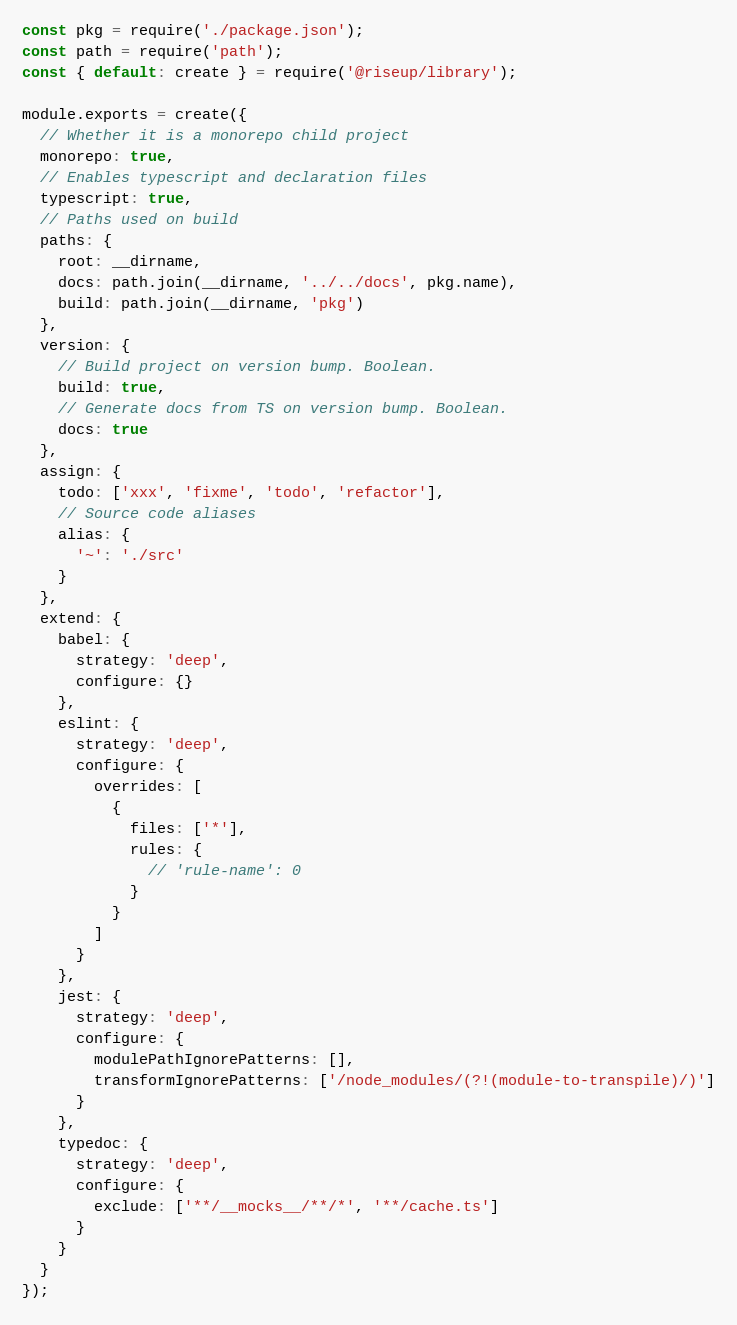<code> <loc_0><loc_0><loc_500><loc_500><_JavaScript_>const pkg = require('./package.json');
const path = require('path');
const { default: create } = require('@riseup/library');

module.exports = create({
  // Whether it is a monorepo child project
  monorepo: true,
  // Enables typescript and declaration files
  typescript: true,
  // Paths used on build
  paths: {
    root: __dirname,
    docs: path.join(__dirname, '../../docs', pkg.name),
    build: path.join(__dirname, 'pkg')
  },
  version: {
    // Build project on version bump. Boolean.
    build: true,
    // Generate docs from TS on version bump. Boolean.
    docs: true
  },
  assign: {
    todo: ['xxx', 'fixme', 'todo', 'refactor'],
    // Source code aliases
    alias: {
      '~': './src'
    }
  },
  extend: {
    babel: {
      strategy: 'deep',
      configure: {}
    },
    eslint: {
      strategy: 'deep',
      configure: {
        overrides: [
          {
            files: ['*'],
            rules: {
              // 'rule-name': 0
            }
          }
        ]
      }
    },
    jest: {
      strategy: 'deep',
      configure: {
        modulePathIgnorePatterns: [],
        transformIgnorePatterns: ['/node_modules/(?!(module-to-transpile)/)']
      }
    },
    typedoc: {
      strategy: 'deep',
      configure: {
        exclude: ['**/__mocks__/**/*', '**/cache.ts']
      }
    }
  }
});
</code> 